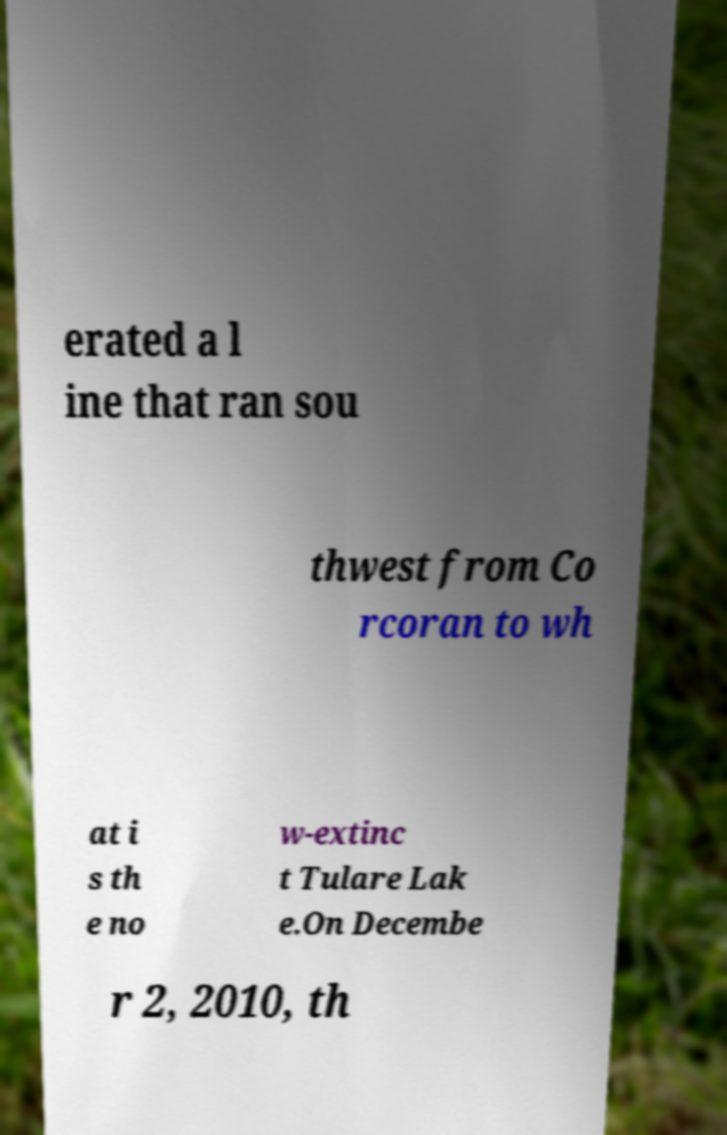For documentation purposes, I need the text within this image transcribed. Could you provide that? erated a l ine that ran sou thwest from Co rcoran to wh at i s th e no w-extinc t Tulare Lak e.On Decembe r 2, 2010, th 